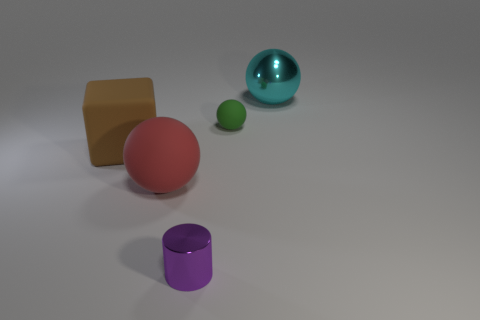What shape is the metal object in front of the cyan shiny sphere? The metal object in front of the cyan shiny sphere is a cylinder. Its reflective purple surface suggests it is made of a material like polished metal, and it has a circular base with a height greater than its radius, which are characteristic features of a cylindrical shape. 